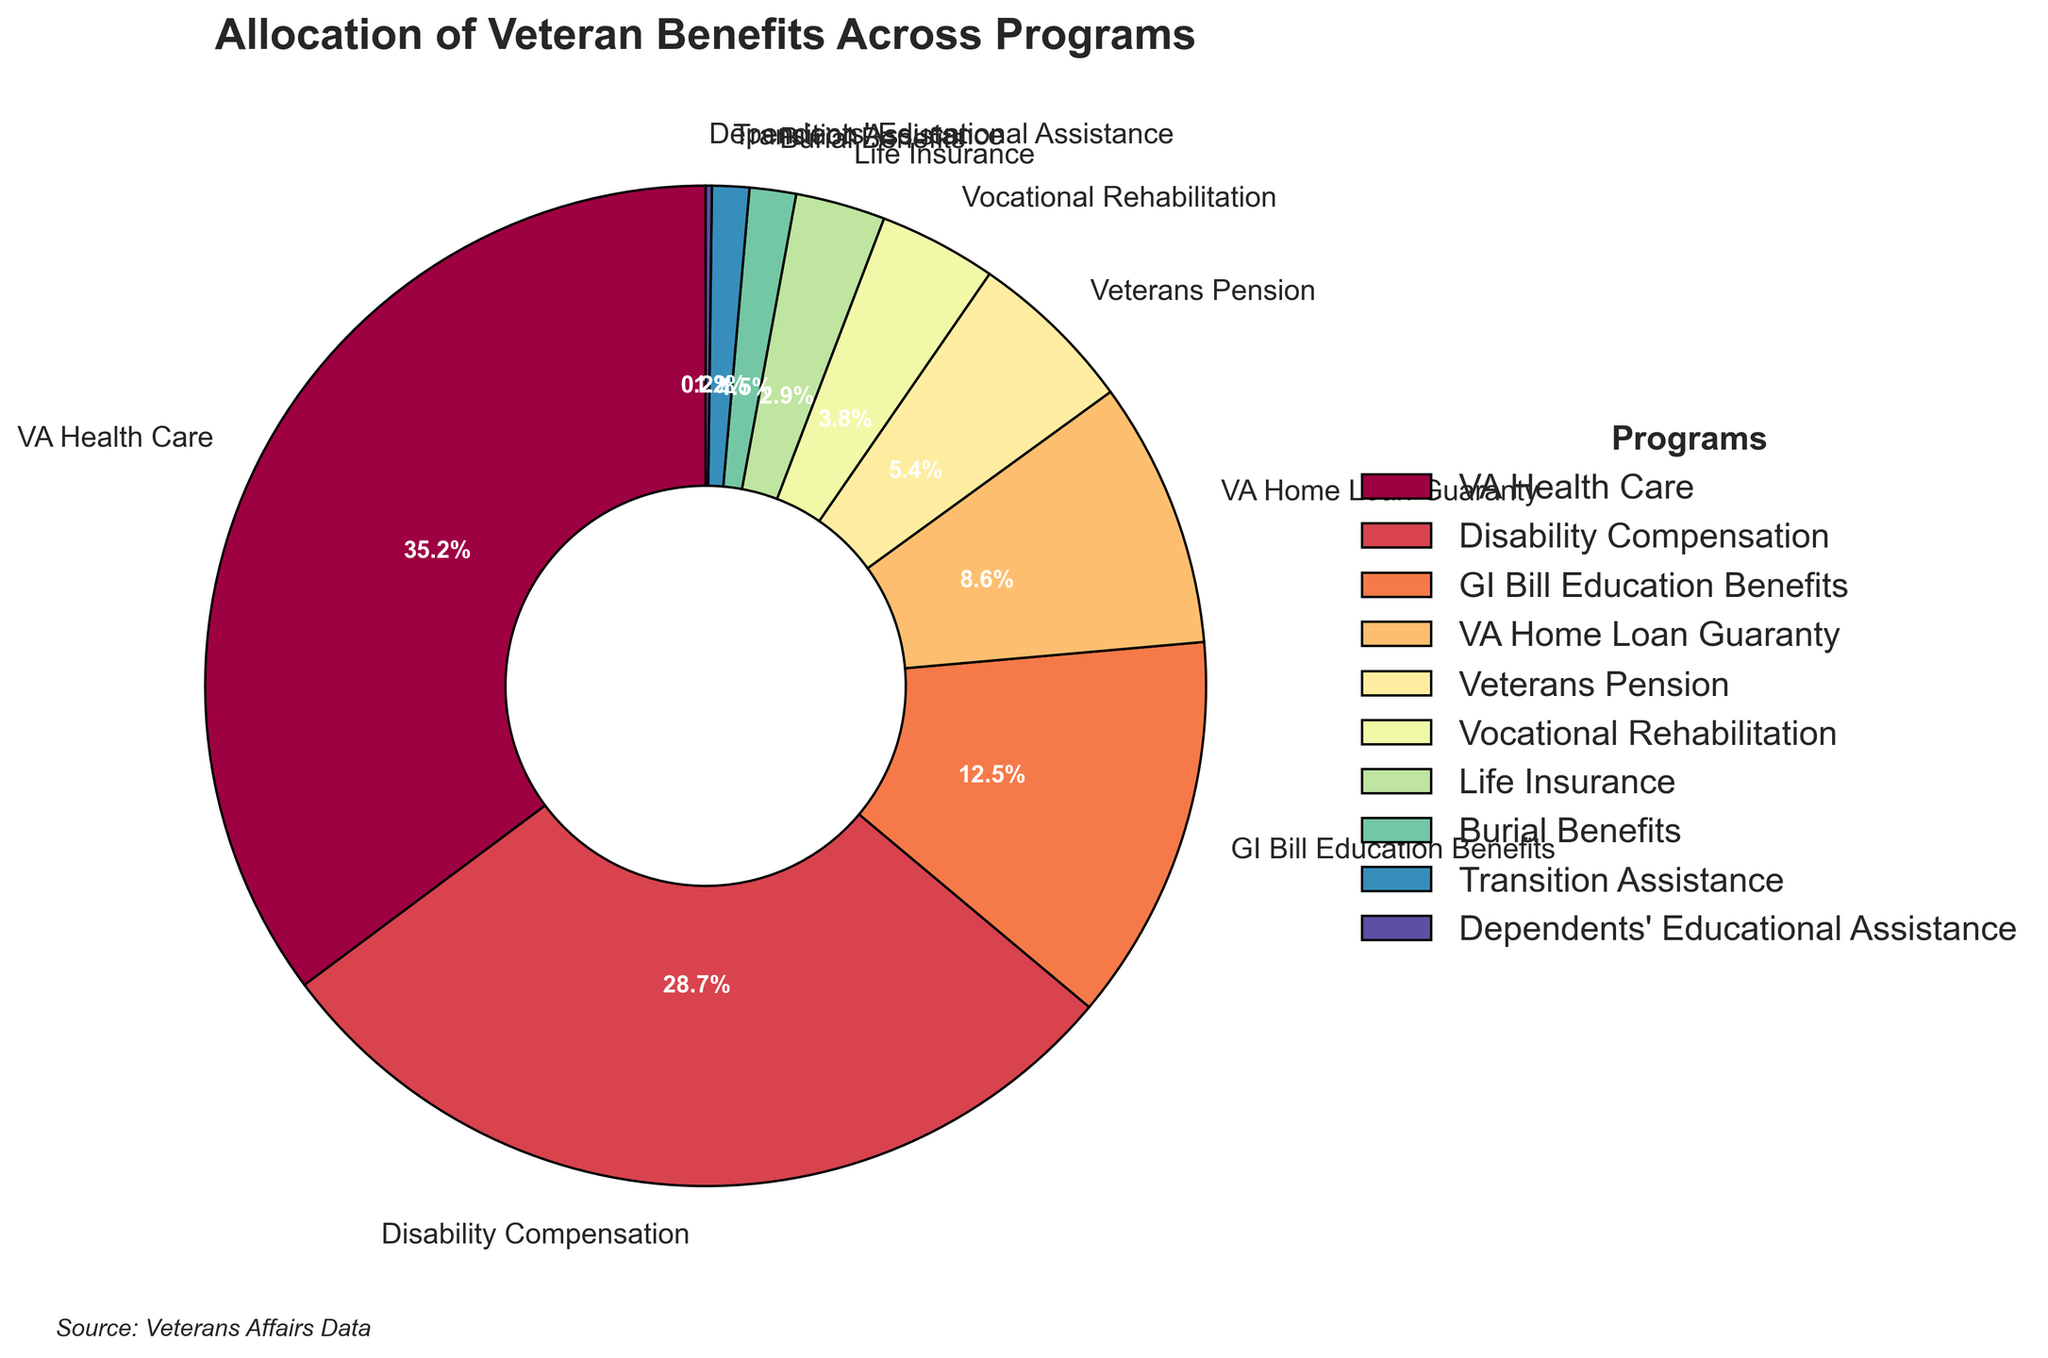Which program receives the highest allocation of veteran benefits? Look at the largest segment of the pie chart. The segment labeled "VA Health Care" has the highest percentage.
Answer: VA Health Care Which program receives the least allocation of veteran benefits? Check the smallest segment of the pie chart. The segment labeled "Dependents' Educational Assistance" has the smallest percentage.
Answer: Dependents' Educational Assistance How much more percentage is allocated to VA Health Care than Disability Compensation? Compare the percentages for VA Health Care and Disability Compensation. Subtract the percentage of Disability Compensation from VA Health Care (35.2 - 28.7).
Answer: 6.5% What is the combined percentage allocation for VA Home Loan Guaranty and Veterans Pension programs? Add the percentages of VA Home Loan Guaranty and Veterans Pension (8.6 + 5.4).
Answer: 14% Is the allocation for GI Bill Education Benefits higher or lower than VA Home Loan Guaranty? Compare the percentages for GI Bill Education Benefits (12.5%) and VA Home Loan Guaranty (8.6%). The allocation for GI Bill Education Benefits is higher.
Answer: Higher By how much is the percentage allocation of Disability Compensation greater than Vocational Rehabilitation? Subtract the percentage of Vocational Rehabilitation from Disability Compensation (28.7 - 3.8).
Answer: 24.9% How does the allocation for Life Insurance compare to Burial Benefits? Compare the percentages for Life Insurance (2.9%) and Burial Benefits (1.5%). The allocation for Life Insurance is higher.
Answer: Higher What is the total percentage allocation for the top three programs? Sum the percentages of the top three programs: VA Health Care (35.2), Disability Compensation (28.7), and GI Bill Education Benefits (12.5). The total is (35.2 + 28.7 + 12.5).
Answer: 76.4% What are the programs with less than 5% allocation? Identify segments with percentages less than 5%. The programs are Veterans Pension (5.4), Vocational Rehabilitation (3.8), Life Insurance (2.9), Burial Benefits (1.5), Transition Assistance (1.2), and Dependents' Educational Assistance (0.2).
Answer: Vocational Rehabilitation, Life Insurance, Burial Benefits, Transition Assistance, Dependents' Educational Assistance What percentage of benefits is allocated to programs categorized as educational assistance (GI Bill Education Benefits and Dependents' Educational Assistance)? Add the percentages of GI Bill Education Benefits and Dependents' Educational Assistance (12.5 + 0.2).
Answer: 12.7% 